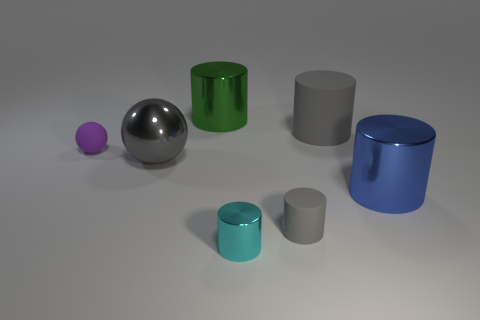Subtract all large blue cylinders. How many cylinders are left? 4 Add 1 big blue things. How many objects exist? 8 Subtract all cyan cylinders. How many red spheres are left? 0 Add 5 tiny cyan objects. How many tiny cyan objects are left? 6 Add 5 green rubber things. How many green rubber things exist? 5 Subtract all cyan cylinders. How many cylinders are left? 4 Subtract 0 brown cylinders. How many objects are left? 7 Subtract all cylinders. How many objects are left? 2 Subtract 3 cylinders. How many cylinders are left? 2 Subtract all brown cylinders. Subtract all blue spheres. How many cylinders are left? 5 